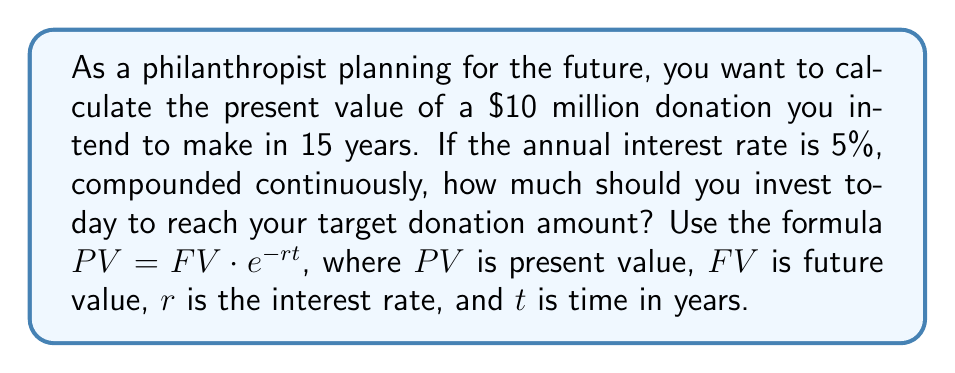Can you answer this question? To solve this problem, we'll use the given formula and the natural logarithm function:

1) We are given:
   $FV = \$10,000,000$
   $r = 5\% = 0.05$
   $t = 15$ years

2) Substitute these values into the formula:
   $PV = 10,000,000 \cdot e^{-0.05 \cdot 15}$

3) Simplify the exponent:
   $PV = 10,000,000 \cdot e^{-0.75}$

4) To calculate this, we can use the natural logarithm function:
   $\ln(PV) = \ln(10,000,000) + \ln(e^{-0.75})$

5) Simplify:
   $\ln(PV) = \ln(10,000,000) - 0.75$

6) Calculate:
   $\ln(PV) \approx 16.1181 - 0.75 = 15.3681$

7) Take $e$ to the power of both sides:
   $PV = e^{15.3681}$

8) Calculate the final result:
   $PV \approx 4,723,665.13$

Therefore, you should invest approximately $4,723,665.13 today to reach your target donation of $10 million in 15 years.
Answer: $4,723,665.13 